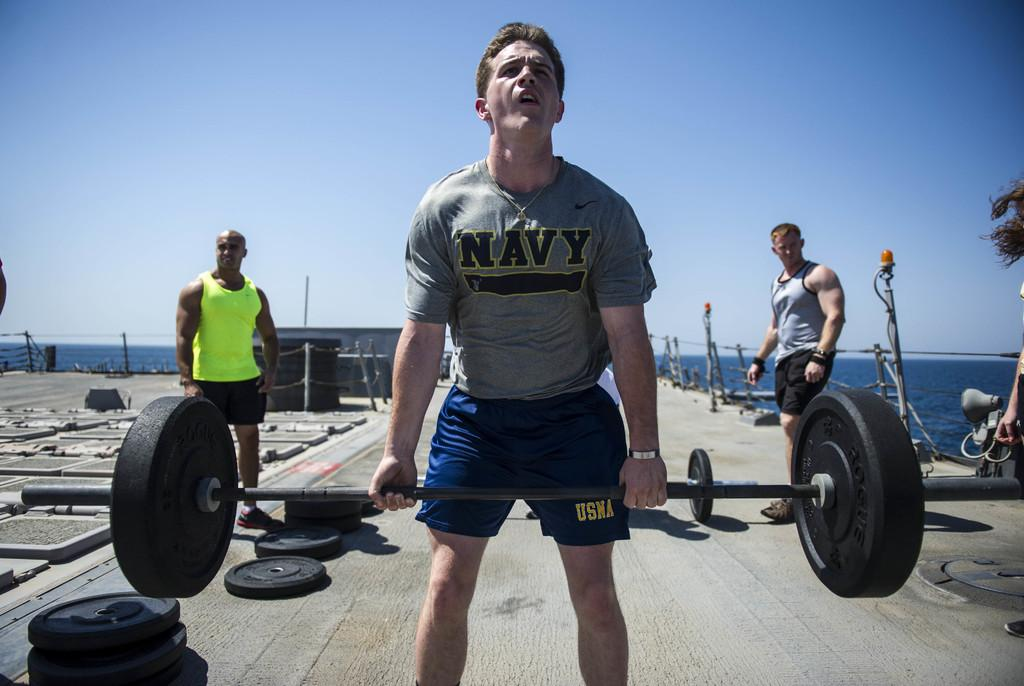Provide a one-sentence caption for the provided image. Three well built men stand outside near the water, one wearing a Navy t-shirt lifting a heavy weight bar. 